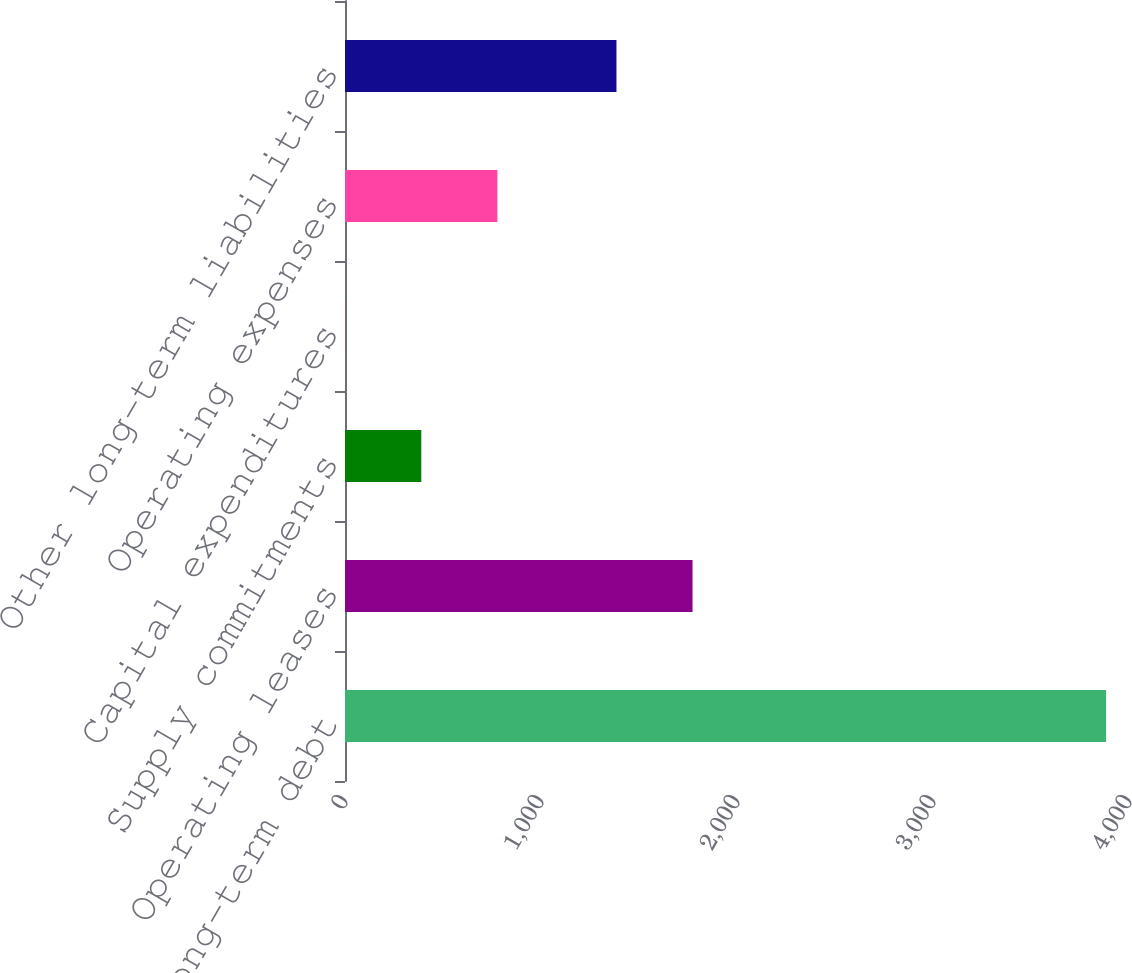Convert chart. <chart><loc_0><loc_0><loc_500><loc_500><bar_chart><fcel>Long-term debt<fcel>Operating leases<fcel>Supply commitments<fcel>Capital expenditures<fcel>Operating expenses<fcel>Other long-term liabilities<nl><fcel>3883<fcel>1773.2<fcel>389.2<fcel>1<fcel>777.4<fcel>1385<nl></chart> 